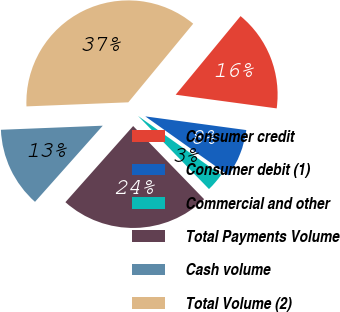Convert chart. <chart><loc_0><loc_0><loc_500><loc_500><pie_chart><fcel>Consumer credit<fcel>Consumer debit (1)<fcel>Commercial and other<fcel>Total Payments Volume<fcel>Cash volume<fcel>Total Volume (2)<nl><fcel>16.16%<fcel>7.68%<fcel>2.92%<fcel>23.83%<fcel>12.79%<fcel>36.62%<nl></chart> 